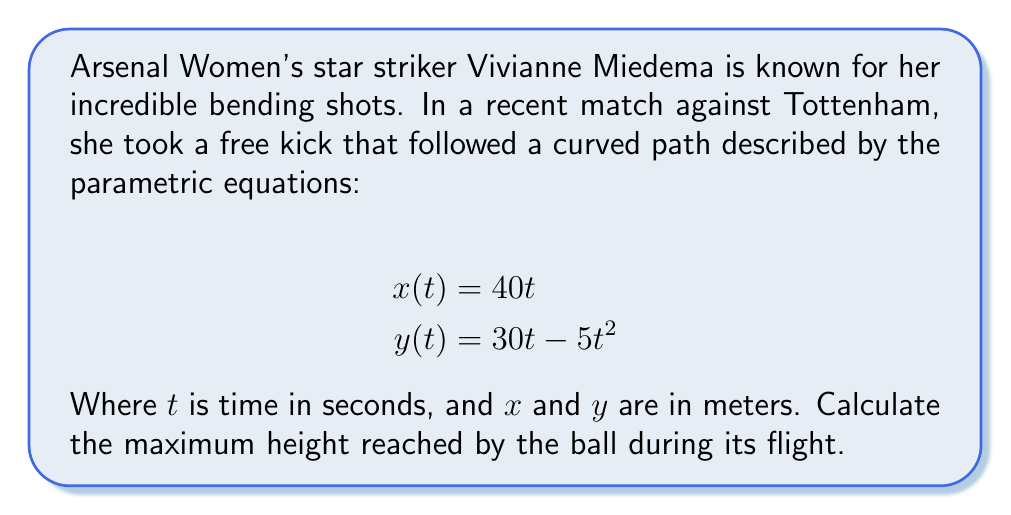Could you help me with this problem? To find the maximum height of the ball's trajectory, we need to determine the highest point of the y-coordinate. This occurs when the vertical velocity (dy/dt) is zero.

Step 1: Find dy/dt
$$\frac{dy}{dt} = 30 - 10t$$

Step 2: Set dy/dt = 0 and solve for t
$$30 - 10t = 0$$
$$-10t = -30$$
$$t = 3$$

Step 3: Substitute t = 3 into the y(t) equation to find the maximum height
$$y(3) = 30(3) - 5(3)^2$$
$$y(3) = 90 - 5(9)$$
$$y(3) = 90 - 45 = 45$$

Therefore, the maximum height reached by the ball is 45 meters.
Answer: 45 meters 